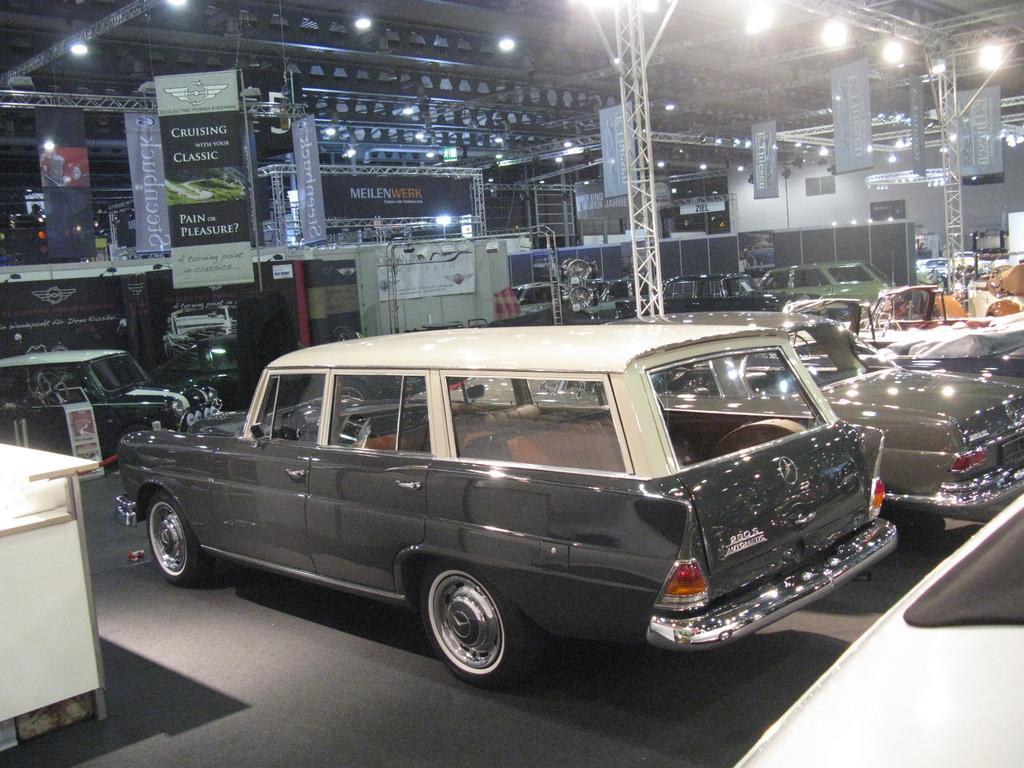Please provide a concise description of this image. In this picture we can see the beams, banners, boards, lights, vehicles, objects and the floor. On the left side of the picture we can see a table. 